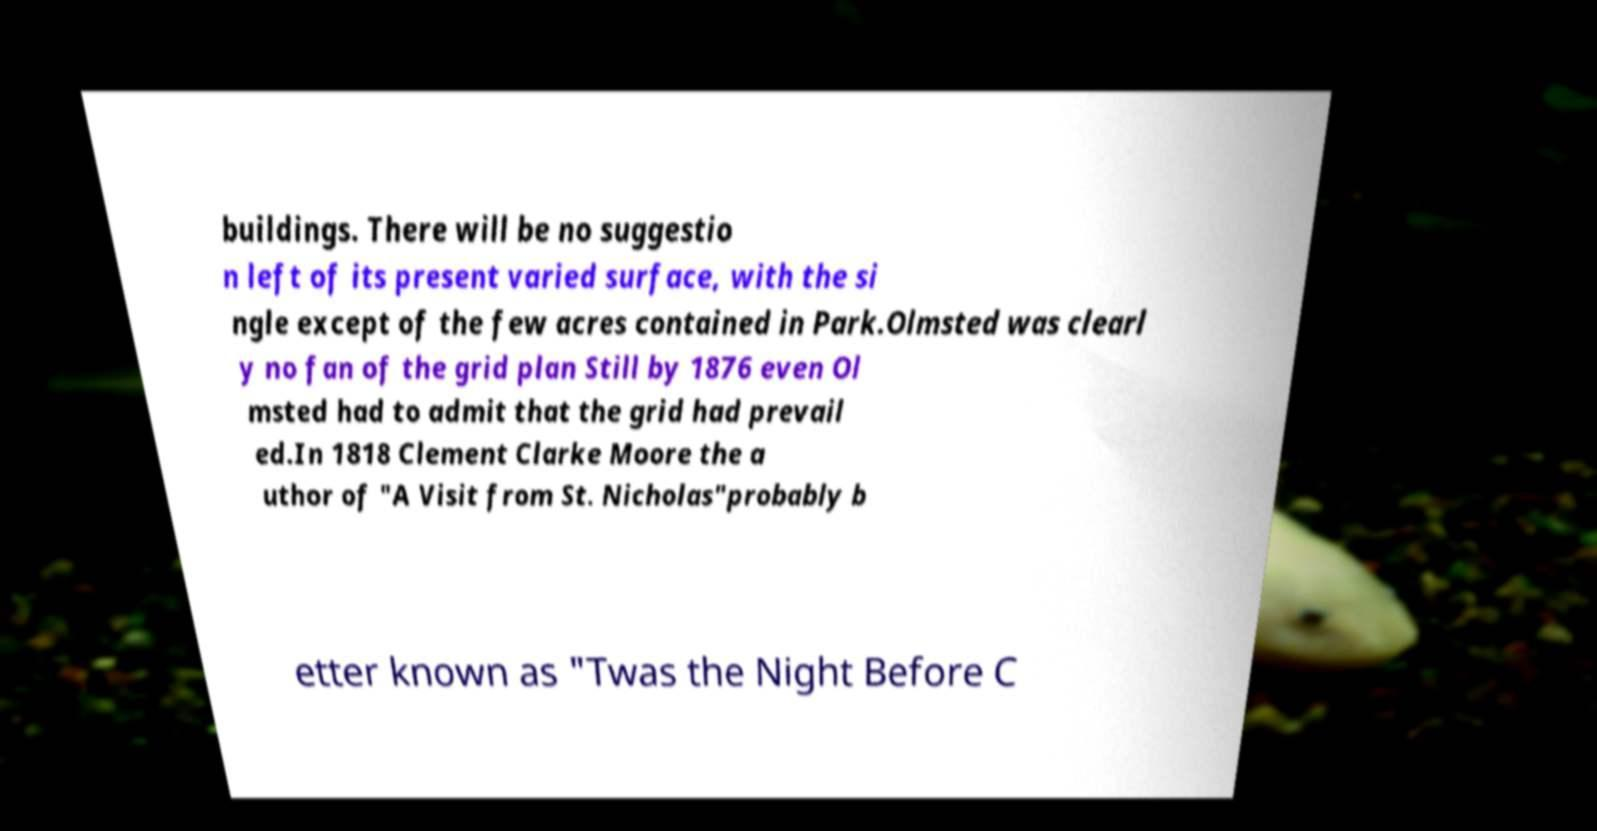There's text embedded in this image that I need extracted. Can you transcribe it verbatim? buildings. There will be no suggestio n left of its present varied surface, with the si ngle except of the few acres contained in Park.Olmsted was clearl y no fan of the grid plan Still by 1876 even Ol msted had to admit that the grid had prevail ed.In 1818 Clement Clarke Moore the a uthor of "A Visit from St. Nicholas"probably b etter known as "Twas the Night Before C 